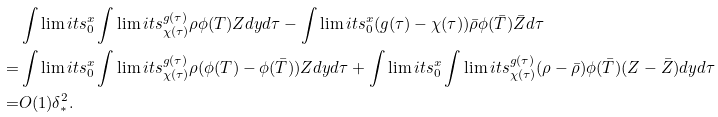<formula> <loc_0><loc_0><loc_500><loc_500>& \int \lim i t s _ { 0 } ^ { x } \int \lim i t s _ { \chi ( \tau ) } ^ { g ( \tau ) } \rho \phi ( T ) Z d y d \tau - \int \lim i t s _ { 0 } ^ { x } ( g ( \tau ) - \chi ( \tau ) ) \bar { \rho } \phi ( \bar { T } ) \bar { Z } d \tau \\ = & \int \lim i t s _ { 0 } ^ { x } \int \lim i t s _ { \chi ( \tau ) } ^ { g ( \tau ) } \rho ( \phi ( T ) - \phi ( \bar { T } ) ) Z d y d \tau + \int \lim i t s _ { 0 } ^ { x } \int \lim i t s _ { \chi ( \tau ) } ^ { g ( \tau ) } ( \rho - \bar { \rho } ) \phi ( \bar { T } ) ( Z - \bar { Z } ) d y d \tau \\ = & O ( 1 ) \delta _ { * } ^ { 2 } .</formula> 